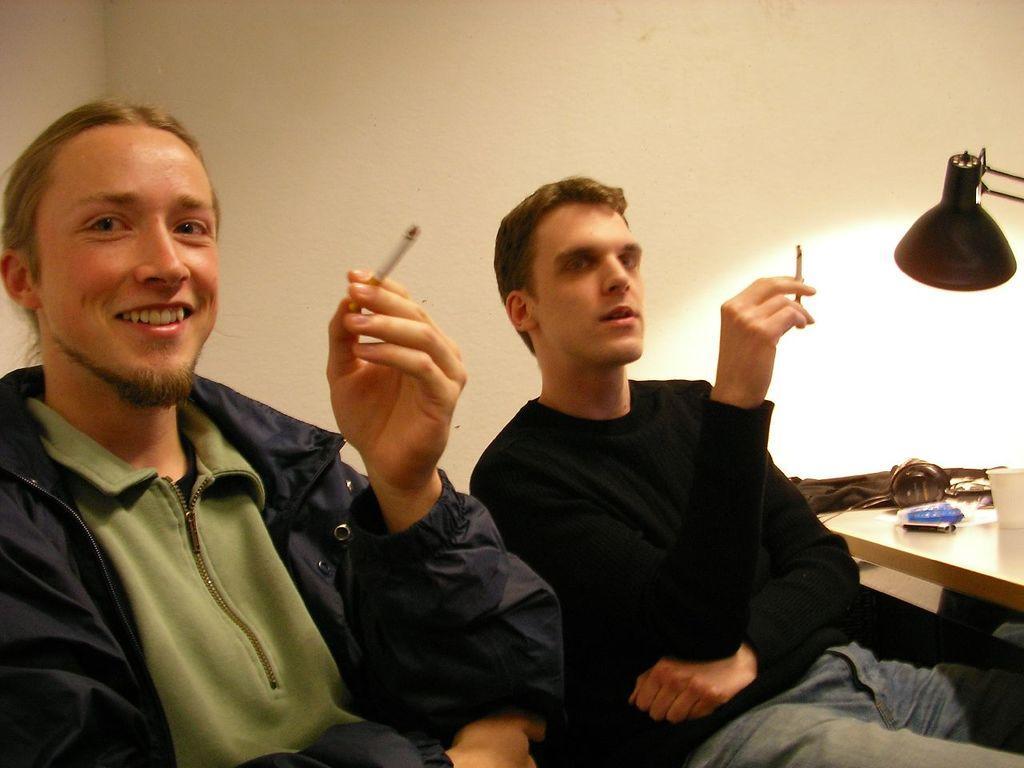How would you summarize this image in a sentence or two? This image consists of a table on the right side. On that there is a glass and a cloth. There is light on the right side. There are two persons in the middle holding cigarettes. 